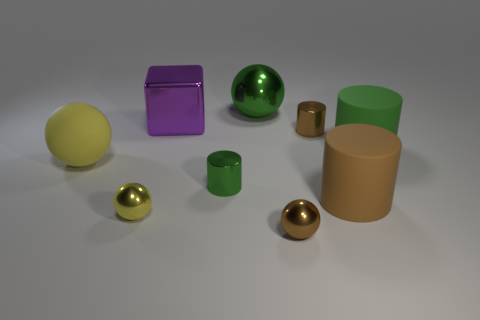Is there a big shiny ball that has the same color as the big rubber ball?
Your response must be concise. No. There is a tiny metallic cylinder that is in front of the tiny brown cylinder; is its color the same as the big rubber cylinder in front of the large yellow rubber thing?
Offer a very short reply. No. What is the shape of the big brown thing?
Your answer should be very brief. Cylinder. What number of tiny green cylinders are on the right side of the small brown cylinder?
Make the answer very short. 0. What number of big yellow objects are made of the same material as the big green sphere?
Your answer should be very brief. 0. Does the green thing that is to the right of the tiny brown metallic sphere have the same material as the large purple cube?
Provide a short and direct response. No. Are there any large purple things?
Provide a succinct answer. Yes. How big is the brown object that is to the left of the large brown cylinder and behind the yellow metallic thing?
Make the answer very short. Small. Is the number of big green spheres on the right side of the green rubber cylinder greater than the number of balls that are on the right side of the big green shiny sphere?
Make the answer very short. No. There is a metal sphere that is the same color as the rubber sphere; what is its size?
Your response must be concise. Small. 